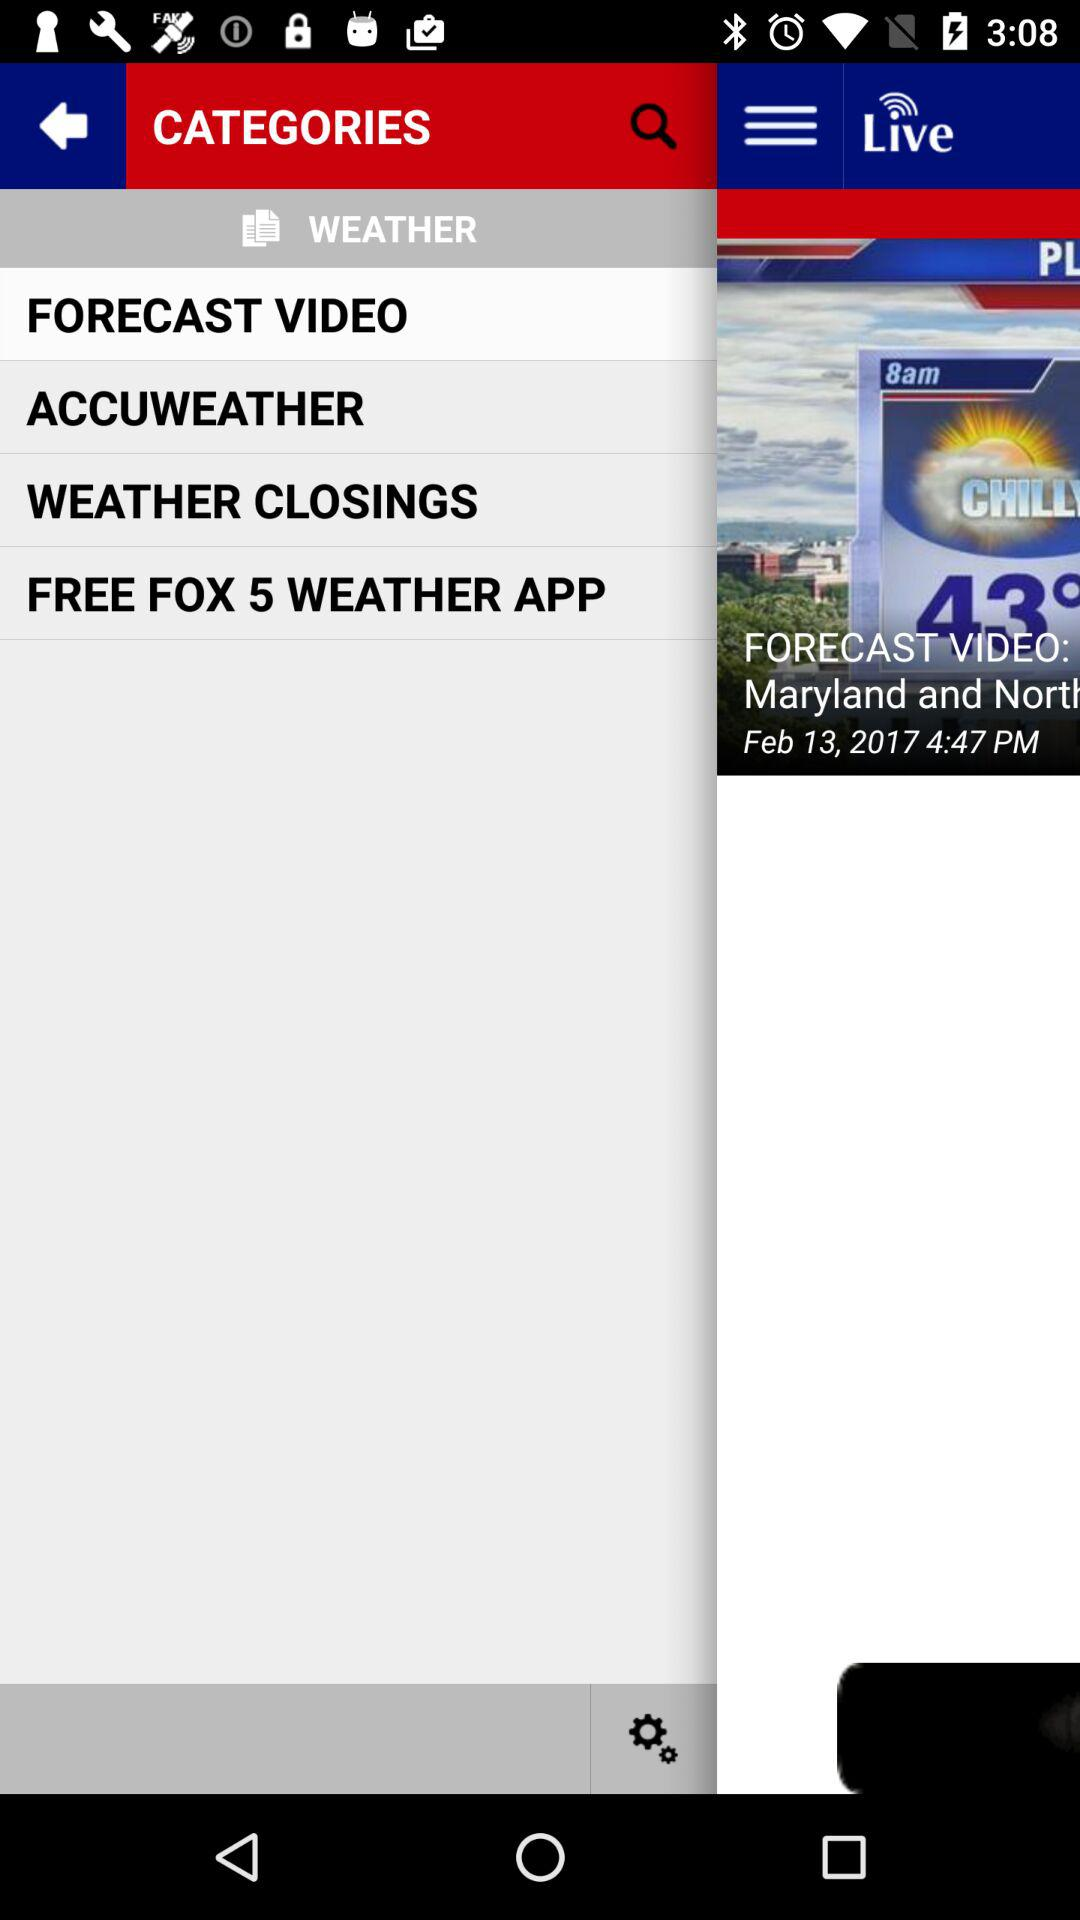How many forecast videos are there?
When the provided information is insufficient, respond with <no answer>. <no answer> 